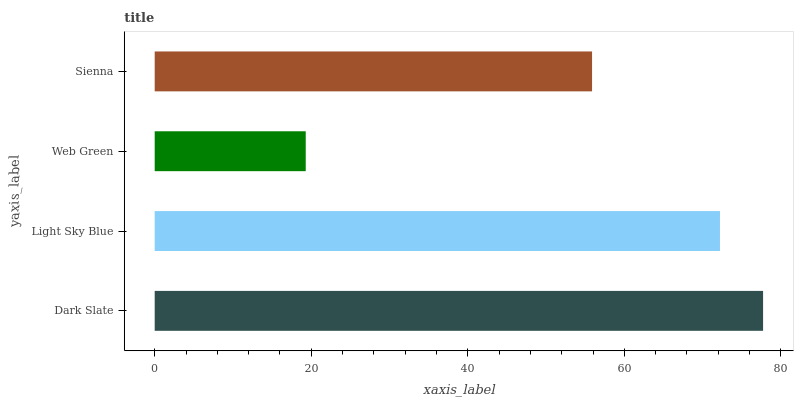Is Web Green the minimum?
Answer yes or no. Yes. Is Dark Slate the maximum?
Answer yes or no. Yes. Is Light Sky Blue the minimum?
Answer yes or no. No. Is Light Sky Blue the maximum?
Answer yes or no. No. Is Dark Slate greater than Light Sky Blue?
Answer yes or no. Yes. Is Light Sky Blue less than Dark Slate?
Answer yes or no. Yes. Is Light Sky Blue greater than Dark Slate?
Answer yes or no. No. Is Dark Slate less than Light Sky Blue?
Answer yes or no. No. Is Light Sky Blue the high median?
Answer yes or no. Yes. Is Sienna the low median?
Answer yes or no. Yes. Is Dark Slate the high median?
Answer yes or no. No. Is Light Sky Blue the low median?
Answer yes or no. No. 